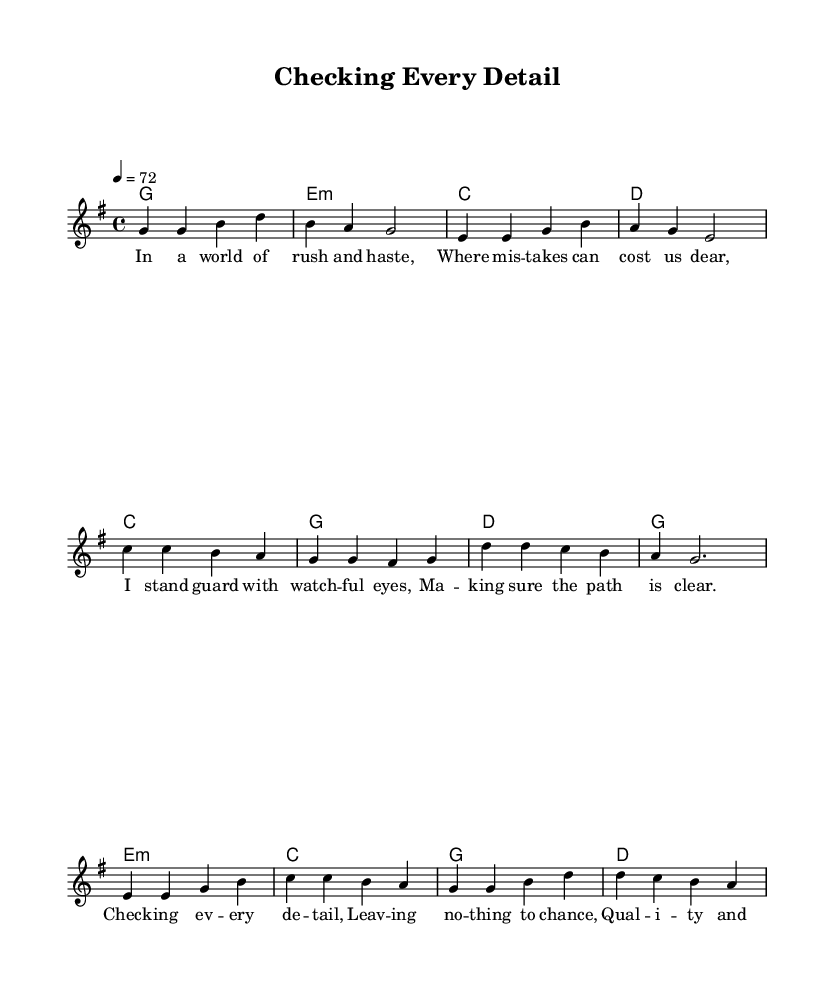What is the key signature of this music? The key signature is G major, which has one sharp (F#). This can be determined by looking for sharps or flats at the beginning of the staff.
Answer: G major What is the time signature of this music? The time signature is 4/4, indicated at the beginning of the piece. This means there are four beats in each measure, and the quarter note gets one beat.
Answer: 4/4 What is the tempo marking for this piece? The tempo marking is "4 = 72", which indicates that there are 72 quarter note beats per minute. This information is found after the time signature at the start of the piece.
Answer: 72 What chord is being played in the first measure? The chord in the first measure is G major, as indicated by the chord symbols written above the staff at the beginning. The notes in the melody also align with the G major triad in the first measure.
Answer: G Which section features the lyrics "Checking every detail"? The lyrics "Checking every detail" are found in the chorus section of the song. By looking at the lyrics placement under the staff, you can determine their section.
Answer: Chorus How many measures are in the bridge section? The bridge section consists of four measures, which can be counted by looking at the bars from where the bridge starts to its end in the sheet music.
Answer: 4 What theme does the song emphasize in relation to quality? The song emphasizes the theme of reliability, as reflected in the lyrics discussing the importance of checking details and ensuring quality. The overall mood and message are consistent with country rock's storytelling tradition.
Answer: Reliability 